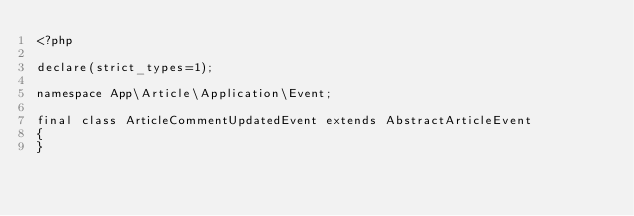<code> <loc_0><loc_0><loc_500><loc_500><_PHP_><?php

declare(strict_types=1);

namespace App\Article\Application\Event;

final class ArticleCommentUpdatedEvent extends AbstractArticleEvent
{
}
</code> 